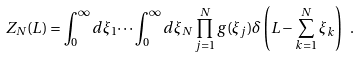<formula> <loc_0><loc_0><loc_500><loc_500>Z _ { N } ( L ) = \int _ { 0 } ^ { \infty } d \xi _ { 1 } \dots \int _ { 0 } ^ { \infty } d \xi _ { N } \prod _ { j = 1 } ^ { N } g ( \xi _ { j } ) \delta \left ( L - \sum _ { k = 1 } ^ { N } \xi _ { k } \right ) \ .</formula> 